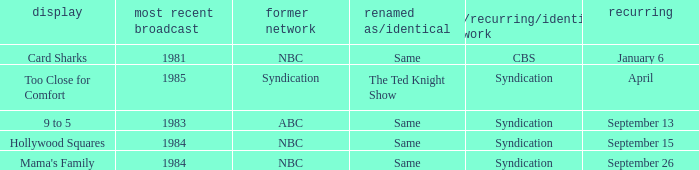When was the show 9 to 5 returning? September 13. 